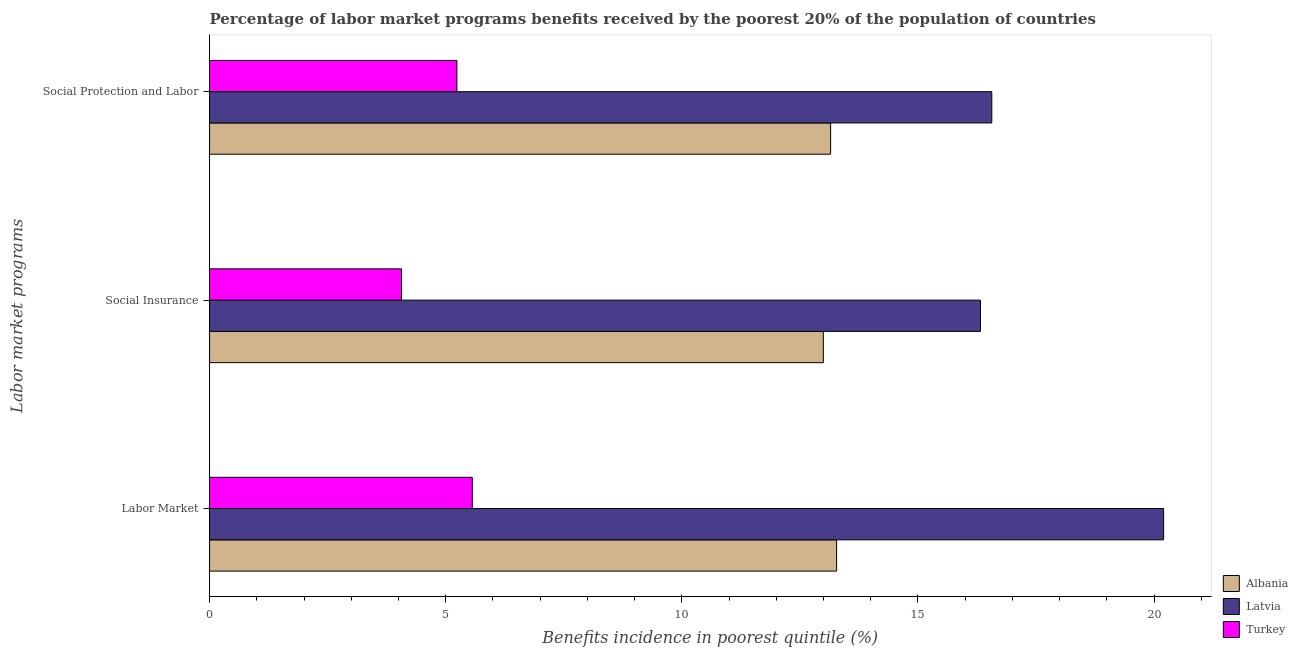How many bars are there on the 1st tick from the top?
Make the answer very short. 3. How many bars are there on the 3rd tick from the bottom?
Keep it short and to the point. 3. What is the label of the 2nd group of bars from the top?
Keep it short and to the point. Social Insurance. What is the percentage of benefits received due to social insurance programs in Albania?
Your response must be concise. 13. Across all countries, what is the maximum percentage of benefits received due to social protection programs?
Provide a succinct answer. 16.56. Across all countries, what is the minimum percentage of benefits received due to social protection programs?
Offer a terse response. 5.24. In which country was the percentage of benefits received due to social insurance programs maximum?
Make the answer very short. Latvia. What is the total percentage of benefits received due to social insurance programs in the graph?
Provide a succinct answer. 33.38. What is the difference between the percentage of benefits received due to labor market programs in Latvia and that in Turkey?
Your answer should be very brief. 14.64. What is the difference between the percentage of benefits received due to labor market programs in Turkey and the percentage of benefits received due to social insurance programs in Albania?
Your answer should be very brief. -7.43. What is the average percentage of benefits received due to social insurance programs per country?
Offer a terse response. 11.13. What is the difference between the percentage of benefits received due to social protection programs and percentage of benefits received due to labor market programs in Turkey?
Offer a terse response. -0.33. What is the ratio of the percentage of benefits received due to labor market programs in Latvia to that in Turkey?
Keep it short and to the point. 3.63. What is the difference between the highest and the second highest percentage of benefits received due to labor market programs?
Make the answer very short. 6.92. What is the difference between the highest and the lowest percentage of benefits received due to social insurance programs?
Give a very brief answer. 12.26. Is the sum of the percentage of benefits received due to social protection programs in Albania and Latvia greater than the maximum percentage of benefits received due to social insurance programs across all countries?
Give a very brief answer. Yes. What does the 3rd bar from the top in Social Insurance represents?
Your response must be concise. Albania. What does the 1st bar from the bottom in Labor Market represents?
Provide a succinct answer. Albania. Are all the bars in the graph horizontal?
Provide a short and direct response. Yes. How many countries are there in the graph?
Your answer should be very brief. 3. What is the difference between two consecutive major ticks on the X-axis?
Make the answer very short. 5. Are the values on the major ticks of X-axis written in scientific E-notation?
Keep it short and to the point. No. Does the graph contain any zero values?
Provide a short and direct response. No. How are the legend labels stacked?
Make the answer very short. Vertical. What is the title of the graph?
Your answer should be very brief. Percentage of labor market programs benefits received by the poorest 20% of the population of countries. Does "Mauritius" appear as one of the legend labels in the graph?
Make the answer very short. No. What is the label or title of the X-axis?
Your answer should be very brief. Benefits incidence in poorest quintile (%). What is the label or title of the Y-axis?
Make the answer very short. Labor market programs. What is the Benefits incidence in poorest quintile (%) in Albania in Labor Market?
Make the answer very short. 13.28. What is the Benefits incidence in poorest quintile (%) in Latvia in Labor Market?
Keep it short and to the point. 20.2. What is the Benefits incidence in poorest quintile (%) in Turkey in Labor Market?
Make the answer very short. 5.56. What is the Benefits incidence in poorest quintile (%) in Albania in Social Insurance?
Provide a succinct answer. 13. What is the Benefits incidence in poorest quintile (%) of Latvia in Social Insurance?
Offer a terse response. 16.32. What is the Benefits incidence in poorest quintile (%) of Turkey in Social Insurance?
Provide a succinct answer. 4.06. What is the Benefits incidence in poorest quintile (%) in Albania in Social Protection and Labor?
Provide a short and direct response. 13.15. What is the Benefits incidence in poorest quintile (%) of Latvia in Social Protection and Labor?
Your answer should be very brief. 16.56. What is the Benefits incidence in poorest quintile (%) in Turkey in Social Protection and Labor?
Offer a terse response. 5.24. Across all Labor market programs, what is the maximum Benefits incidence in poorest quintile (%) of Albania?
Give a very brief answer. 13.28. Across all Labor market programs, what is the maximum Benefits incidence in poorest quintile (%) of Latvia?
Your answer should be compact. 20.2. Across all Labor market programs, what is the maximum Benefits incidence in poorest quintile (%) of Turkey?
Your response must be concise. 5.56. Across all Labor market programs, what is the minimum Benefits incidence in poorest quintile (%) in Albania?
Offer a very short reply. 13. Across all Labor market programs, what is the minimum Benefits incidence in poorest quintile (%) of Latvia?
Your response must be concise. 16.32. Across all Labor market programs, what is the minimum Benefits incidence in poorest quintile (%) of Turkey?
Give a very brief answer. 4.06. What is the total Benefits incidence in poorest quintile (%) in Albania in the graph?
Provide a succinct answer. 39.42. What is the total Benefits incidence in poorest quintile (%) of Latvia in the graph?
Your answer should be very brief. 53.09. What is the total Benefits incidence in poorest quintile (%) in Turkey in the graph?
Make the answer very short. 14.87. What is the difference between the Benefits incidence in poorest quintile (%) in Albania in Labor Market and that in Social Insurance?
Your answer should be compact. 0.28. What is the difference between the Benefits incidence in poorest quintile (%) in Latvia in Labor Market and that in Social Insurance?
Ensure brevity in your answer.  3.88. What is the difference between the Benefits incidence in poorest quintile (%) in Turkey in Labor Market and that in Social Insurance?
Offer a very short reply. 1.5. What is the difference between the Benefits incidence in poorest quintile (%) of Albania in Labor Market and that in Social Protection and Labor?
Your answer should be compact. 0.13. What is the difference between the Benefits incidence in poorest quintile (%) of Latvia in Labor Market and that in Social Protection and Labor?
Ensure brevity in your answer.  3.64. What is the difference between the Benefits incidence in poorest quintile (%) of Turkey in Labor Market and that in Social Protection and Labor?
Offer a terse response. 0.33. What is the difference between the Benefits incidence in poorest quintile (%) in Albania in Social Insurance and that in Social Protection and Labor?
Your answer should be compact. -0.15. What is the difference between the Benefits incidence in poorest quintile (%) in Latvia in Social Insurance and that in Social Protection and Labor?
Ensure brevity in your answer.  -0.24. What is the difference between the Benefits incidence in poorest quintile (%) in Turkey in Social Insurance and that in Social Protection and Labor?
Give a very brief answer. -1.17. What is the difference between the Benefits incidence in poorest quintile (%) in Albania in Labor Market and the Benefits incidence in poorest quintile (%) in Latvia in Social Insurance?
Keep it short and to the point. -3.05. What is the difference between the Benefits incidence in poorest quintile (%) in Albania in Labor Market and the Benefits incidence in poorest quintile (%) in Turkey in Social Insurance?
Your answer should be very brief. 9.21. What is the difference between the Benefits incidence in poorest quintile (%) of Latvia in Labor Market and the Benefits incidence in poorest quintile (%) of Turkey in Social Insurance?
Keep it short and to the point. 16.14. What is the difference between the Benefits incidence in poorest quintile (%) of Albania in Labor Market and the Benefits incidence in poorest quintile (%) of Latvia in Social Protection and Labor?
Keep it short and to the point. -3.29. What is the difference between the Benefits incidence in poorest quintile (%) in Albania in Labor Market and the Benefits incidence in poorest quintile (%) in Turkey in Social Protection and Labor?
Ensure brevity in your answer.  8.04. What is the difference between the Benefits incidence in poorest quintile (%) of Latvia in Labor Market and the Benefits incidence in poorest quintile (%) of Turkey in Social Protection and Labor?
Offer a very short reply. 14.96. What is the difference between the Benefits incidence in poorest quintile (%) of Albania in Social Insurance and the Benefits incidence in poorest quintile (%) of Latvia in Social Protection and Labor?
Your answer should be compact. -3.57. What is the difference between the Benefits incidence in poorest quintile (%) in Albania in Social Insurance and the Benefits incidence in poorest quintile (%) in Turkey in Social Protection and Labor?
Your answer should be very brief. 7.76. What is the difference between the Benefits incidence in poorest quintile (%) of Latvia in Social Insurance and the Benefits incidence in poorest quintile (%) of Turkey in Social Protection and Labor?
Provide a succinct answer. 11.09. What is the average Benefits incidence in poorest quintile (%) of Albania per Labor market programs?
Your response must be concise. 13.14. What is the average Benefits incidence in poorest quintile (%) in Latvia per Labor market programs?
Your answer should be compact. 17.7. What is the average Benefits incidence in poorest quintile (%) in Turkey per Labor market programs?
Give a very brief answer. 4.96. What is the difference between the Benefits incidence in poorest quintile (%) in Albania and Benefits incidence in poorest quintile (%) in Latvia in Labor Market?
Your answer should be very brief. -6.92. What is the difference between the Benefits incidence in poorest quintile (%) in Albania and Benefits incidence in poorest quintile (%) in Turkey in Labor Market?
Make the answer very short. 7.71. What is the difference between the Benefits incidence in poorest quintile (%) in Latvia and Benefits incidence in poorest quintile (%) in Turkey in Labor Market?
Your response must be concise. 14.64. What is the difference between the Benefits incidence in poorest quintile (%) of Albania and Benefits incidence in poorest quintile (%) of Latvia in Social Insurance?
Your response must be concise. -3.33. What is the difference between the Benefits incidence in poorest quintile (%) in Albania and Benefits incidence in poorest quintile (%) in Turkey in Social Insurance?
Make the answer very short. 8.93. What is the difference between the Benefits incidence in poorest quintile (%) of Latvia and Benefits incidence in poorest quintile (%) of Turkey in Social Insurance?
Provide a short and direct response. 12.26. What is the difference between the Benefits incidence in poorest quintile (%) in Albania and Benefits incidence in poorest quintile (%) in Latvia in Social Protection and Labor?
Keep it short and to the point. -3.41. What is the difference between the Benefits incidence in poorest quintile (%) of Albania and Benefits incidence in poorest quintile (%) of Turkey in Social Protection and Labor?
Give a very brief answer. 7.91. What is the difference between the Benefits incidence in poorest quintile (%) in Latvia and Benefits incidence in poorest quintile (%) in Turkey in Social Protection and Labor?
Give a very brief answer. 11.33. What is the ratio of the Benefits incidence in poorest quintile (%) in Albania in Labor Market to that in Social Insurance?
Offer a very short reply. 1.02. What is the ratio of the Benefits incidence in poorest quintile (%) of Latvia in Labor Market to that in Social Insurance?
Offer a very short reply. 1.24. What is the ratio of the Benefits incidence in poorest quintile (%) in Turkey in Labor Market to that in Social Insurance?
Your answer should be very brief. 1.37. What is the ratio of the Benefits incidence in poorest quintile (%) of Albania in Labor Market to that in Social Protection and Labor?
Offer a very short reply. 1.01. What is the ratio of the Benefits incidence in poorest quintile (%) of Latvia in Labor Market to that in Social Protection and Labor?
Provide a short and direct response. 1.22. What is the ratio of the Benefits incidence in poorest quintile (%) of Turkey in Labor Market to that in Social Protection and Labor?
Make the answer very short. 1.06. What is the ratio of the Benefits incidence in poorest quintile (%) in Albania in Social Insurance to that in Social Protection and Labor?
Your response must be concise. 0.99. What is the ratio of the Benefits incidence in poorest quintile (%) in Latvia in Social Insurance to that in Social Protection and Labor?
Give a very brief answer. 0.99. What is the ratio of the Benefits incidence in poorest quintile (%) of Turkey in Social Insurance to that in Social Protection and Labor?
Your answer should be compact. 0.78. What is the difference between the highest and the second highest Benefits incidence in poorest quintile (%) of Albania?
Ensure brevity in your answer.  0.13. What is the difference between the highest and the second highest Benefits incidence in poorest quintile (%) of Latvia?
Offer a terse response. 3.64. What is the difference between the highest and the second highest Benefits incidence in poorest quintile (%) in Turkey?
Provide a succinct answer. 0.33. What is the difference between the highest and the lowest Benefits incidence in poorest quintile (%) in Albania?
Your answer should be very brief. 0.28. What is the difference between the highest and the lowest Benefits incidence in poorest quintile (%) of Latvia?
Your answer should be very brief. 3.88. What is the difference between the highest and the lowest Benefits incidence in poorest quintile (%) of Turkey?
Ensure brevity in your answer.  1.5. 